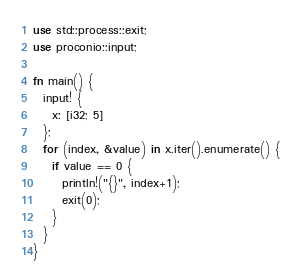Convert code to text. <code><loc_0><loc_0><loc_500><loc_500><_Rust_>use std::process::exit;
use proconio::input;

fn main() {
  input! {
    x: [i32; 5]
  };
  for (index, &value) in x.iter().enumerate() {
    if value == 0 { 
      println!("{}", index+1);
      exit(0);
    }
  }
}</code> 